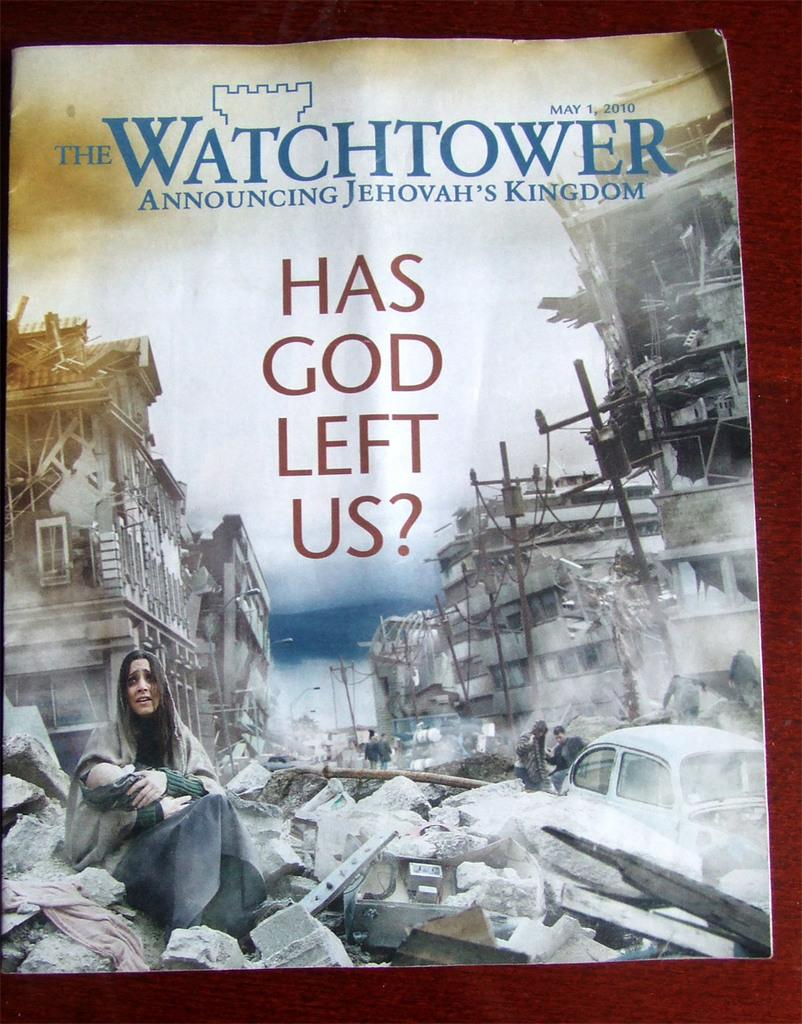What is depicted on the paper in the image? The paper contains a drawing of buildings. Are there any words or letters on the paper? Yes, there is text on the paper. Where is the person sitting in the image? The person is sitting on stones in the image. What type of noise can be heard coming from the cactus in the image? There is no cactus present in the image, so it is not possible to determine what, if any, noise might be heard. 